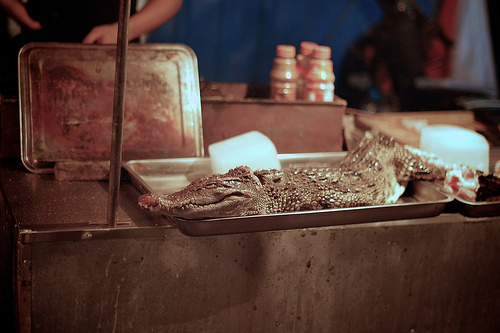<image>
Is the alligator behind the tray? No. The alligator is not behind the tray. From this viewpoint, the alligator appears to be positioned elsewhere in the scene. 